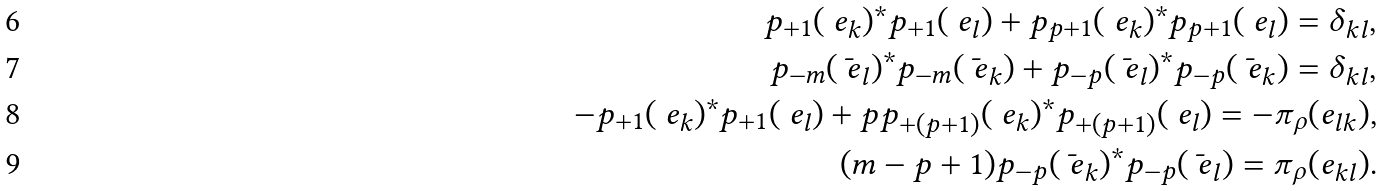<formula> <loc_0><loc_0><loc_500><loc_500>p _ { + 1 } ( \ e _ { k } ) ^ { \ast } p _ { + 1 } ( \ e _ { l } ) + p _ { p + 1 } ( \ e _ { k } ) ^ { \ast } p _ { p + 1 } ( \ e _ { l } ) = \delta _ { k l } , \\ p _ { - m } ( \bar { \ e } _ { l } ) ^ { \ast } p _ { - m } ( \bar { \ e } _ { k } ) + p _ { - p } ( \bar { \ e } _ { l } ) ^ { \ast } p _ { - p } ( \bar { \ e } _ { k } ) = \delta _ { k l } , \\ - p _ { + 1 } ( \ e _ { k } ) ^ { \ast } p _ { + 1 } ( \ e _ { l } ) + p p _ { + ( p + 1 ) } ( \ e _ { k } ) ^ { \ast } p _ { + ( p + 1 ) } ( \ e _ { l } ) = - \pi _ { \rho } ( e _ { l k } ) , \\ ( m - p + 1 ) p _ { - p } ( \bar { \ e } _ { k } ) ^ { \ast } p _ { - p } ( \bar { \ e } _ { l } ) = \pi _ { \rho } ( e _ { k l } ) .</formula> 